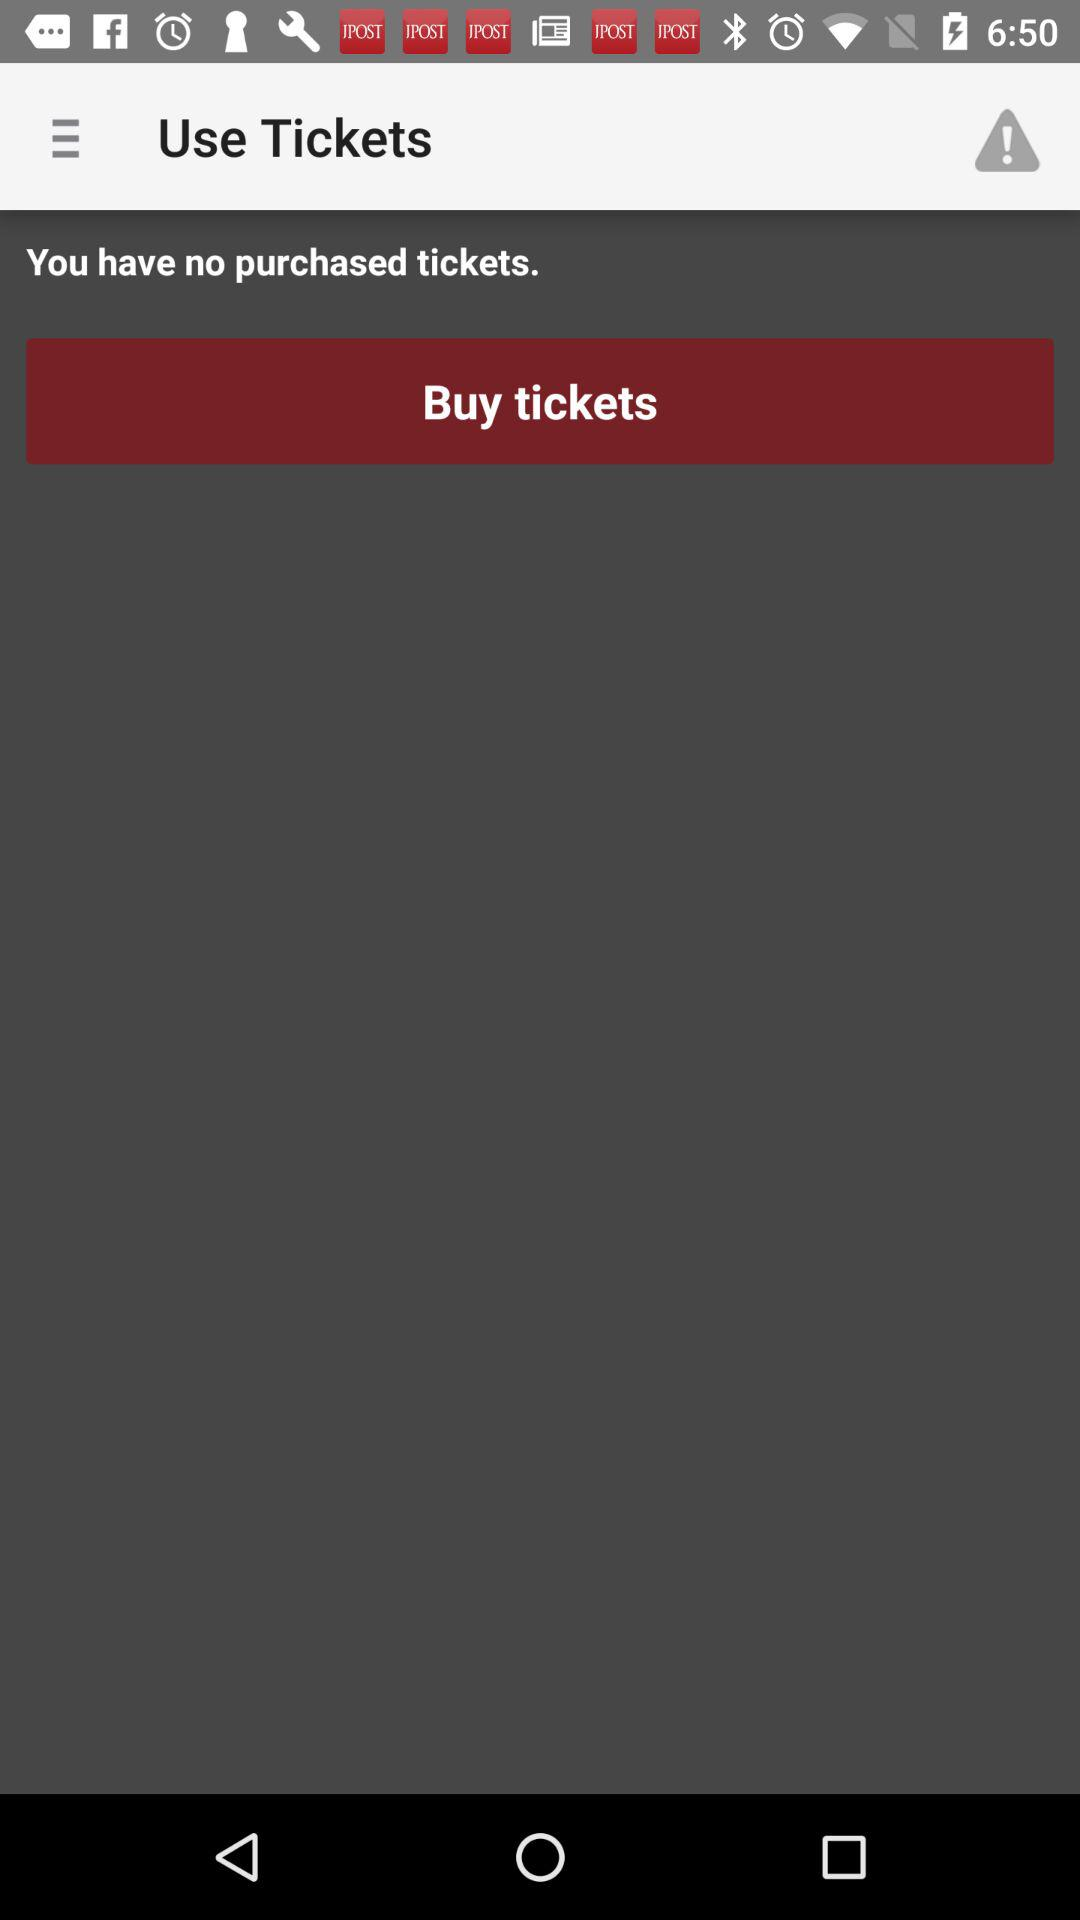How many tickets do I have?
Answer the question using a single word or phrase. 0 